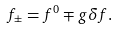Convert formula to latex. <formula><loc_0><loc_0><loc_500><loc_500>f _ { \pm } = f ^ { 0 } \mp g \delta f .</formula> 